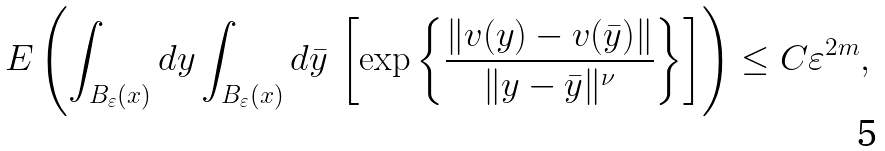<formula> <loc_0><loc_0><loc_500><loc_500>E \left ( \int _ { B _ { \varepsilon } ( x ) } d y \int _ { B _ { \varepsilon } ( x ) } d \bar { y } \, \left [ \exp \left \{ \frac { \| v ( y ) - v ( \bar { y } ) \| } { \| y - \bar { y } \| ^ { \nu } } \right \} \right ] \right ) \leq C \varepsilon ^ { 2 m } ,</formula> 